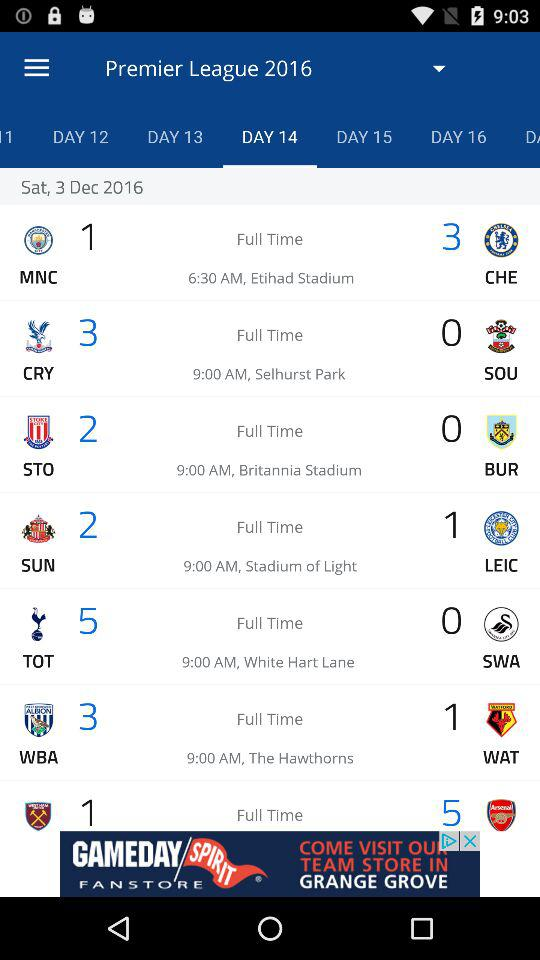What is the selected day number? The selected day number is "DAY 14". 